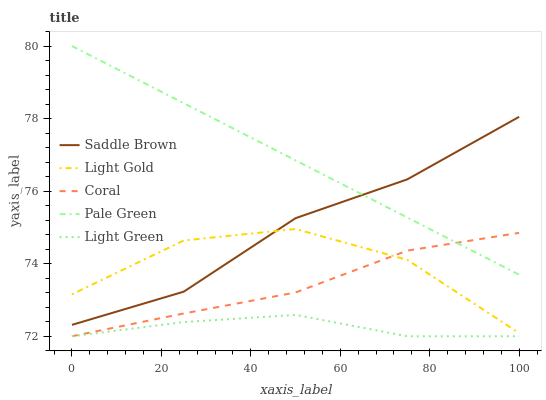Does Light Green have the minimum area under the curve?
Answer yes or no. Yes. Does Pale Green have the maximum area under the curve?
Answer yes or no. Yes. Does Light Gold have the minimum area under the curve?
Answer yes or no. No. Does Light Gold have the maximum area under the curve?
Answer yes or no. No. Is Pale Green the smoothest?
Answer yes or no. Yes. Is Light Gold the roughest?
Answer yes or no. Yes. Is Light Gold the smoothest?
Answer yes or no. No. Is Pale Green the roughest?
Answer yes or no. No. Does Coral have the lowest value?
Answer yes or no. Yes. Does Light Gold have the lowest value?
Answer yes or no. No. Does Pale Green have the highest value?
Answer yes or no. Yes. Does Light Gold have the highest value?
Answer yes or no. No. Is Light Gold less than Pale Green?
Answer yes or no. Yes. Is Light Gold greater than Light Green?
Answer yes or no. Yes. Does Coral intersect Light Green?
Answer yes or no. Yes. Is Coral less than Light Green?
Answer yes or no. No. Is Coral greater than Light Green?
Answer yes or no. No. Does Light Gold intersect Pale Green?
Answer yes or no. No. 